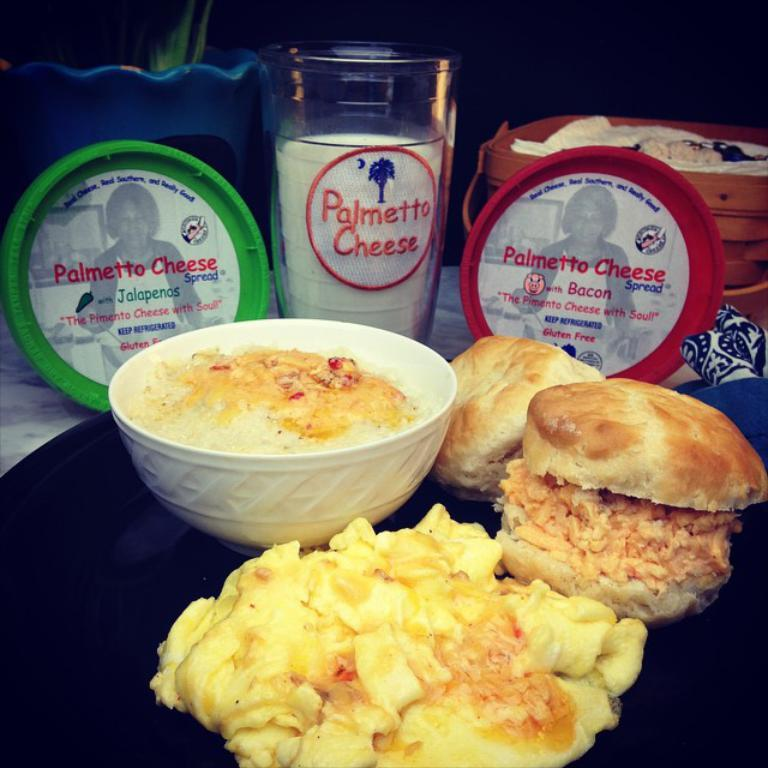What type of food can be seen on the table in the image? There is food placed on the table in the image, including a burger. Can you describe any other food items visible on the table? Unfortunately, the provided facts do not mention any other specific food items. What can be seen in the background of the image? There is a blue color flower pot in the background. How would you describe the overall lighting in the image? The background of the image is dark. What type of straw is being used to decorate the church in the image? There is no church or straw present in the image; it features food on a table and a blue color flower pot in the background. 